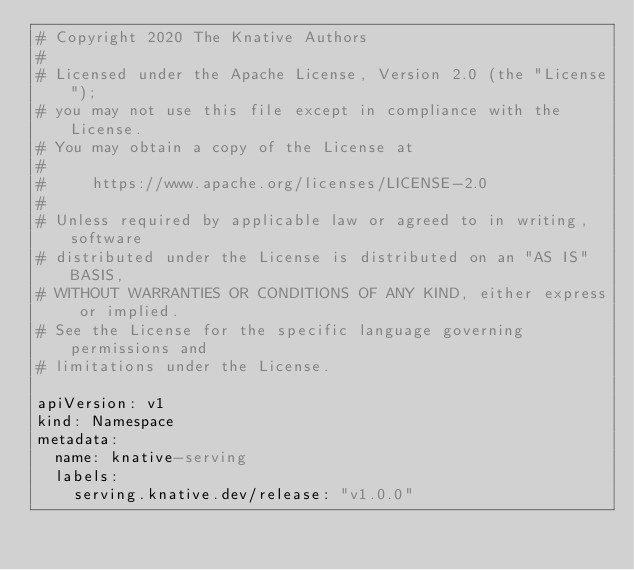<code> <loc_0><loc_0><loc_500><loc_500><_YAML_># Copyright 2020 The Knative Authors
#
# Licensed under the Apache License, Version 2.0 (the "License");
# you may not use this file except in compliance with the License.
# You may obtain a copy of the License at
#
#     https://www.apache.org/licenses/LICENSE-2.0
#
# Unless required by applicable law or agreed to in writing, software
# distributed under the License is distributed on an "AS IS" BASIS,
# WITHOUT WARRANTIES OR CONDITIONS OF ANY KIND, either express or implied.
# See the License for the specific language governing permissions and
# limitations under the License.

apiVersion: v1
kind: Namespace
metadata:
  name: knative-serving
  labels:
    serving.knative.dev/release: "v1.0.0"
</code> 